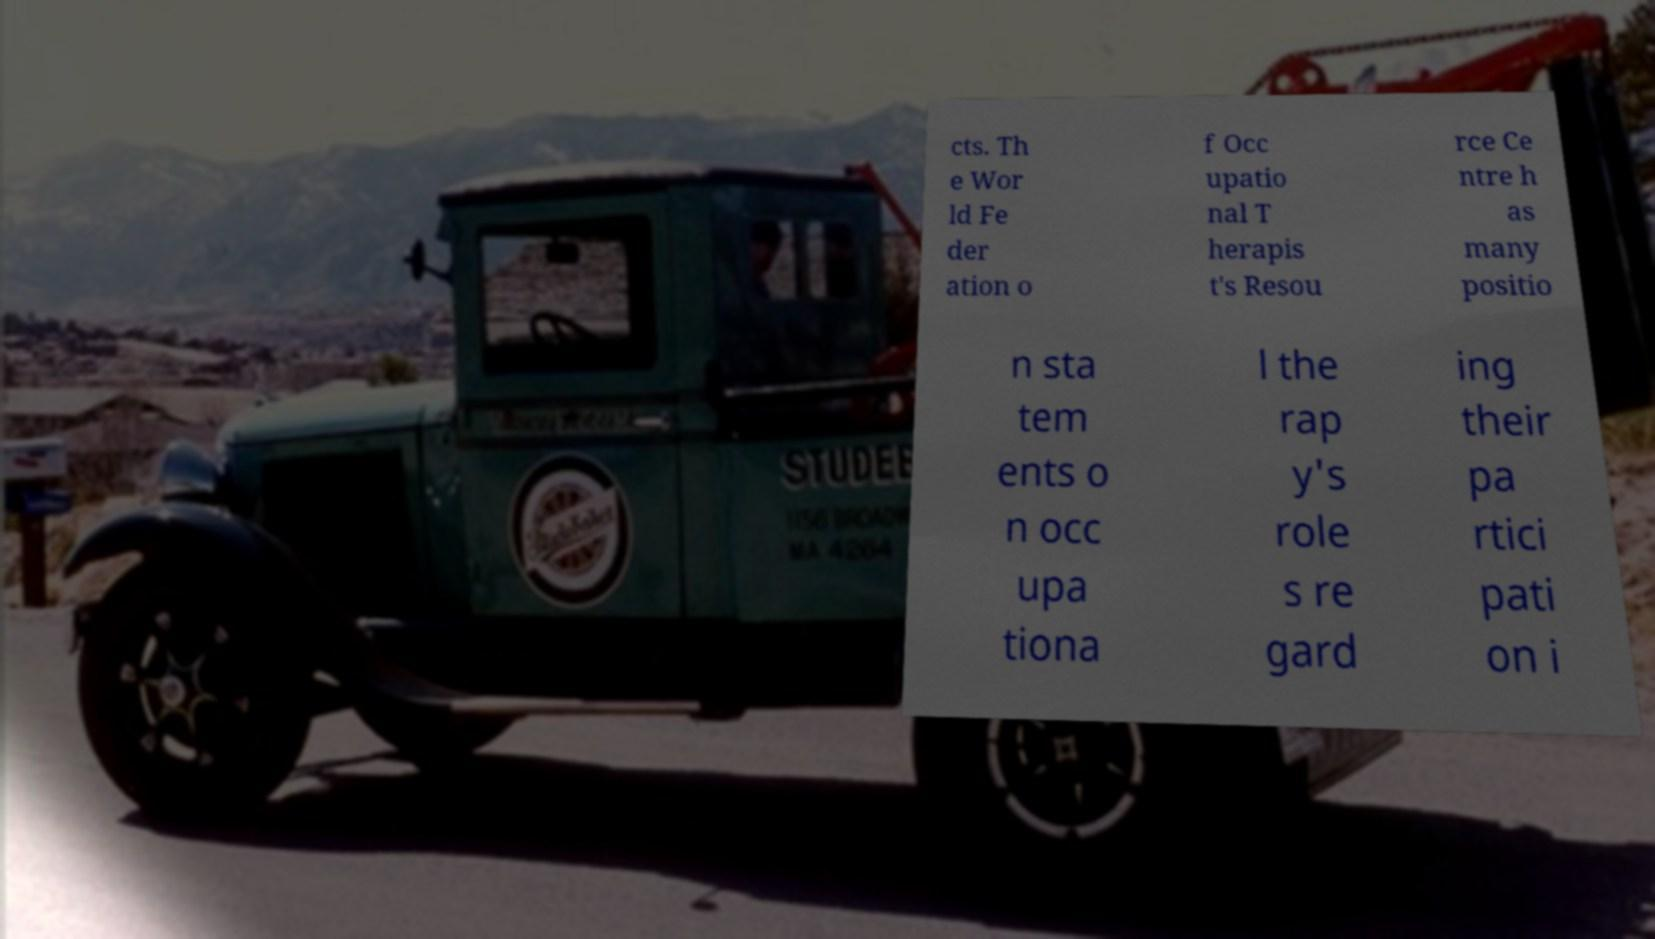I need the written content from this picture converted into text. Can you do that? cts. Th e Wor ld Fe der ation o f Occ upatio nal T herapis t's Resou rce Ce ntre h as many positio n sta tem ents o n occ upa tiona l the rap y's role s re gard ing their pa rtici pati on i 